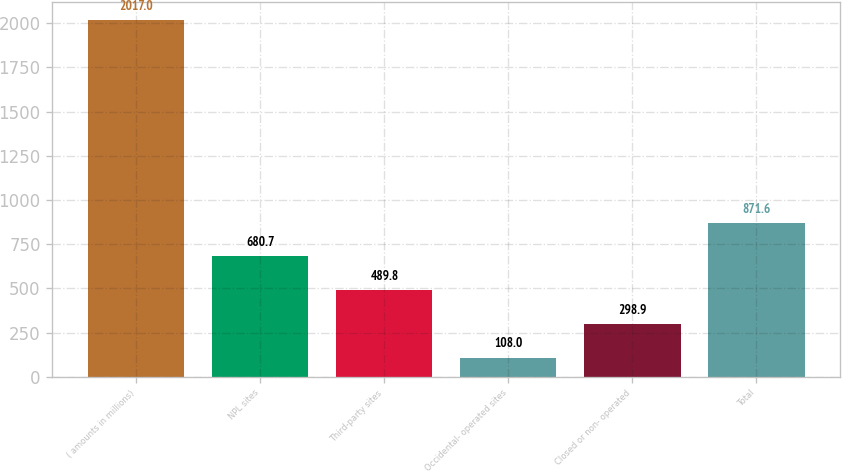Convert chart. <chart><loc_0><loc_0><loc_500><loc_500><bar_chart><fcel>( amounts in millions)<fcel>NPL sites<fcel>Third-party sites<fcel>Occidental- operated sites<fcel>Closed or non- operated<fcel>Total<nl><fcel>2017<fcel>680.7<fcel>489.8<fcel>108<fcel>298.9<fcel>871.6<nl></chart> 